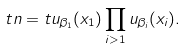<formula> <loc_0><loc_0><loc_500><loc_500>t n = t u _ { \beta _ { 1 } } ( x _ { 1 } ) \prod _ { i > 1 } u _ { \beta _ { i } } ( x _ { i } ) .</formula> 